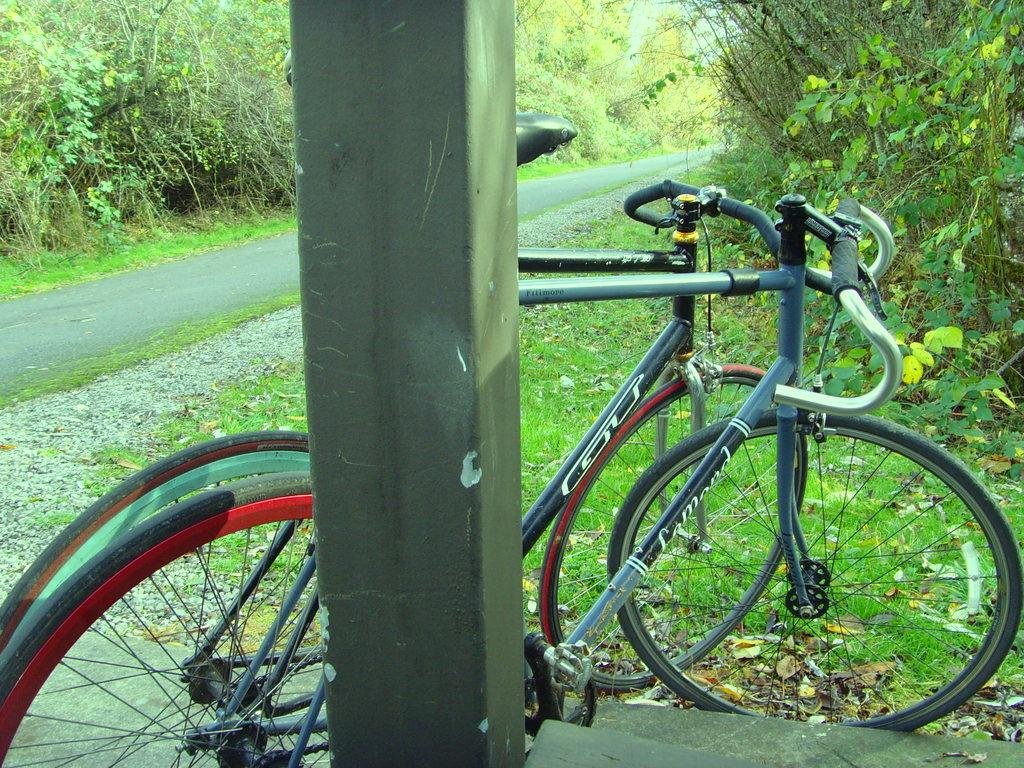What is the main object in the image? There is a bicycle in the image. What type of surface can be seen in the image? There is a road in the image. What type of vegetation is visible in the image? Grass and plants are present in the image. What structure can be seen in the image? There is a pole in the image. Can you see any blood on the bicycle in the image? There is no blood visible on the bicycle or in the image. Is there a hose connected to the pole in the image? There is no hose present in the image. 